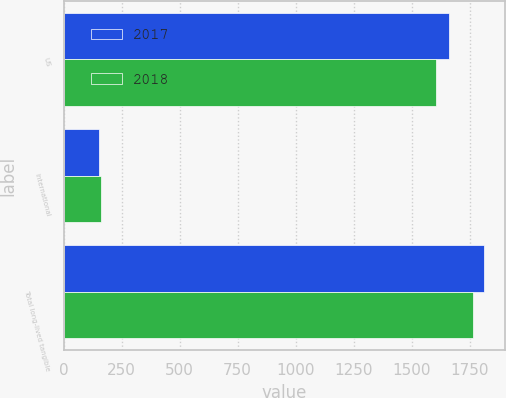Convert chart to OTSL. <chart><loc_0><loc_0><loc_500><loc_500><stacked_bar_chart><ecel><fcel>US<fcel>International<fcel>Total long-lived tangible<nl><fcel>2017<fcel>1661<fcel>151<fcel>1812<nl><fcel>2018<fcel>1603<fcel>160<fcel>1763<nl></chart> 